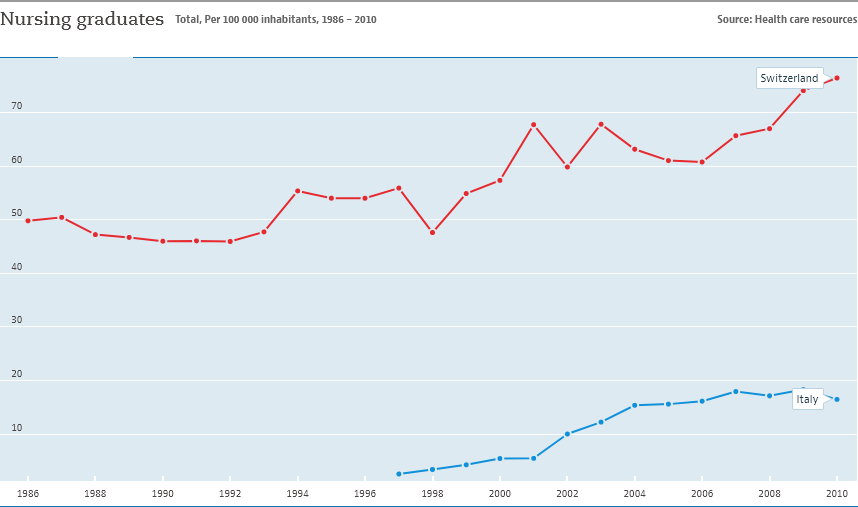Specify some key components in this picture. The given graph compares the GDP per capita of two countries, Switzerland and Italy. In 2010, the highest number of nursing graduates was recorded in Switzerland. 